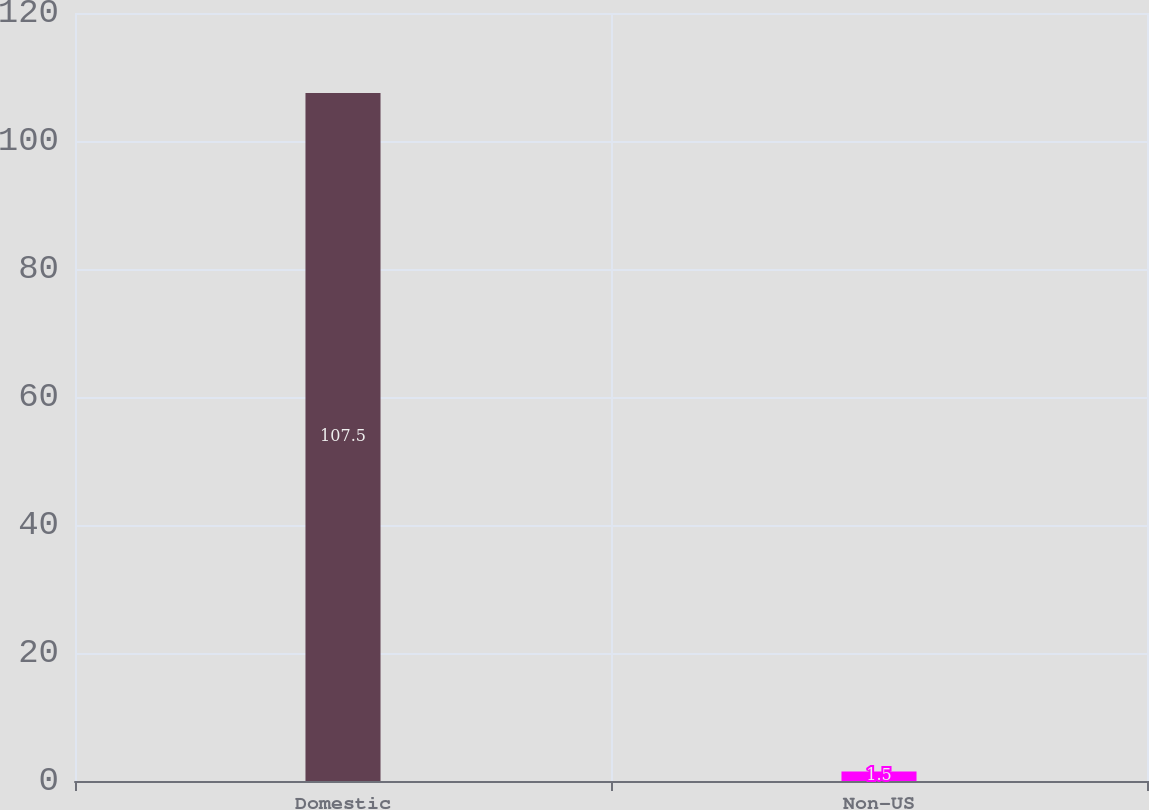<chart> <loc_0><loc_0><loc_500><loc_500><bar_chart><fcel>Domestic<fcel>Non-US<nl><fcel>107.5<fcel>1.5<nl></chart> 